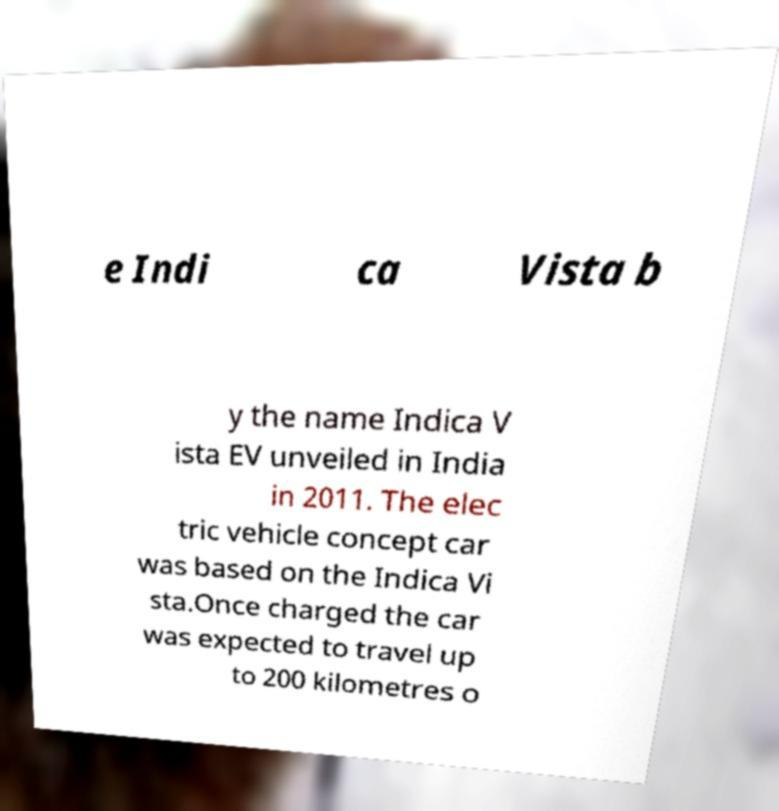What messages or text are displayed in this image? I need them in a readable, typed format. e Indi ca Vista b y the name Indica V ista EV unveiled in India in 2011. The elec tric vehicle concept car was based on the Indica Vi sta.Once charged the car was expected to travel up to 200 kilometres o 